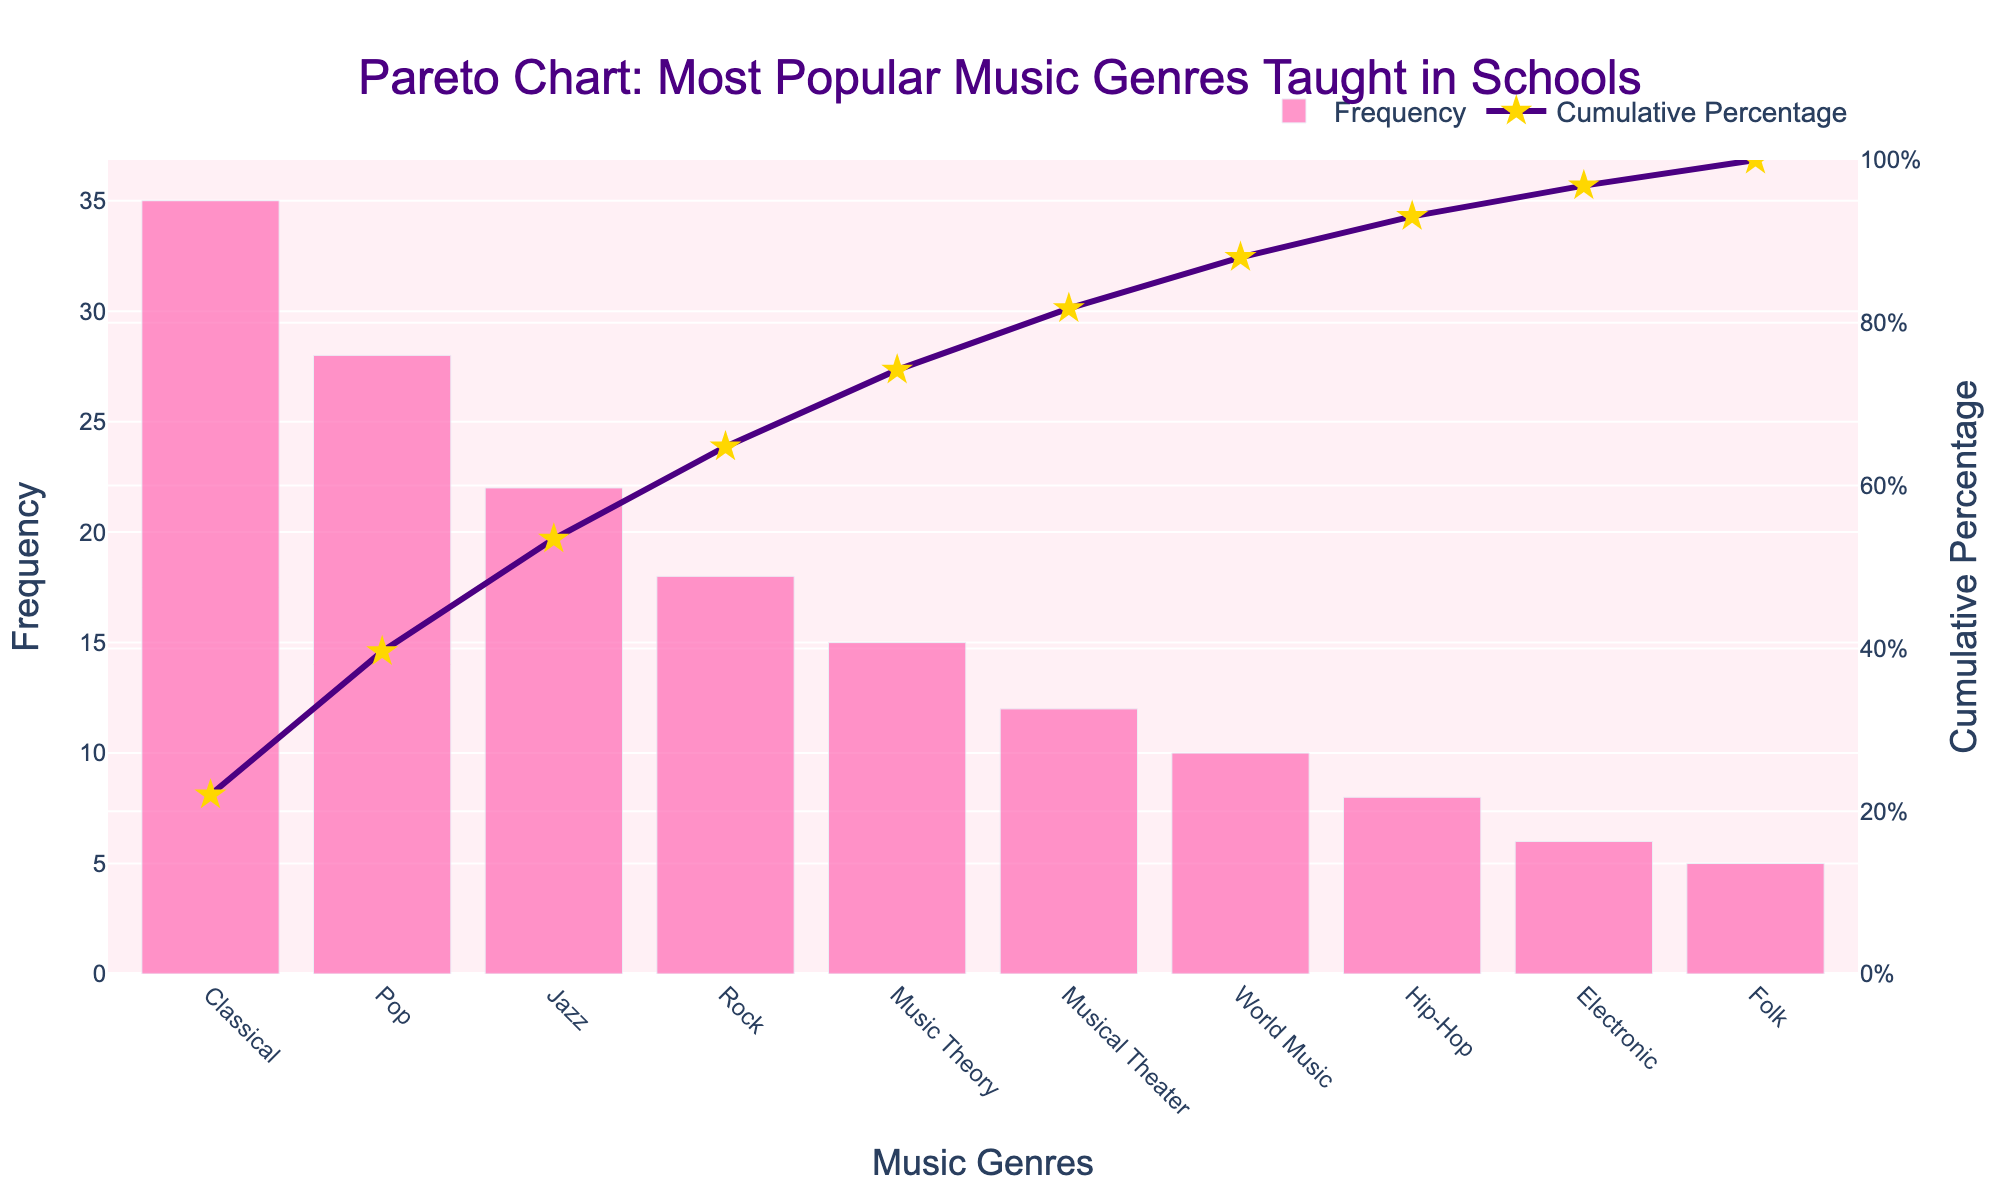What is the most popular music genre taught in schools? The most popular music genre can be identified by finding the genre with the highest frequency in the bar chart. In this case, it is the first bar in the plot.
Answer: Classical What is the cumulative percentage after Pop music? The cumulative percentage for Pop music can be directly read from the cumulative percentage line. It is the second point on the purple line.
Answer: 51.35% How many music genres have a frequency higher than 20? Count the bars that have a height greater than 20. These genres are Classical, Pop, and Jazz.
Answer: 3 Which music genre has the lowest frequency? Identify the shortest bar in the bar chart, which represents the genre with the lowest frequency.
Answer: Folk What is the cumulative percentage for the first three music genres? Sum the cumulative percentages for Classical, Pop, and Jazz. These percentages are 35%, 51.35%, and 72.97%. So, the total is 72.97%.
Answer: 72.97% How much more popular is Jazz compared to Folk? Subtract the frequency of Folk from the frequency of Jazz. Jazz has 22, and Folk has 5. The difference is 22 - 5.
Answer: 17 Which music genre accounts for the highest increase in cumulative percentage after its inclusion? Look at the segment-wise increase in cumulative percentage from one genre to the next. The highest increase is from Pop (35%) to Pop + Jazz (72.97%), considering the percentage points change.
Answer: Jazz What proportion of the cumulative percentage is covered by the top four genres? Calculate the cumulative percentage of the first four genres summed together: Classical (35), Pop (51.35), Jazz (72.97), Rock (83.78). Sum these percentages for the top four genres.
Answer: 83.78% What's the difference in frequency between Pop and Rock? Subtract the frequency of Rock from the frequency of Pop. Pop has 28, and Rock has 18.
Answer: 10 Which genre represents the 80% mark in the cumulative percentage? Locate the genre corresponding to the cumulative percentage closest to 80%. From the chart, this genre is Rock, as its cumulative percentage is 83.78%, which is just past 80%.
Answer: Rock 